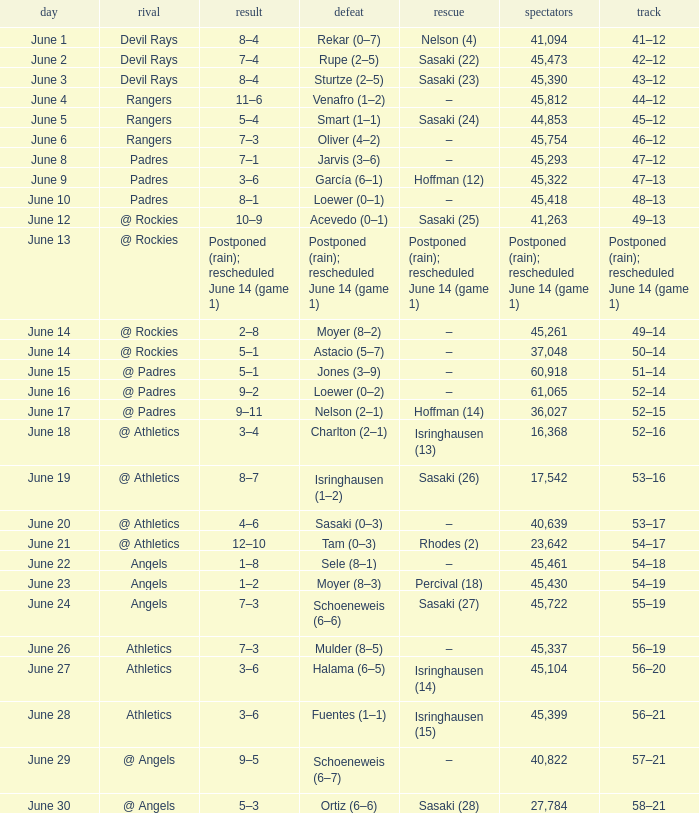What was the attendance of the Mariners game when they had a record of 56–20? 45104.0. 